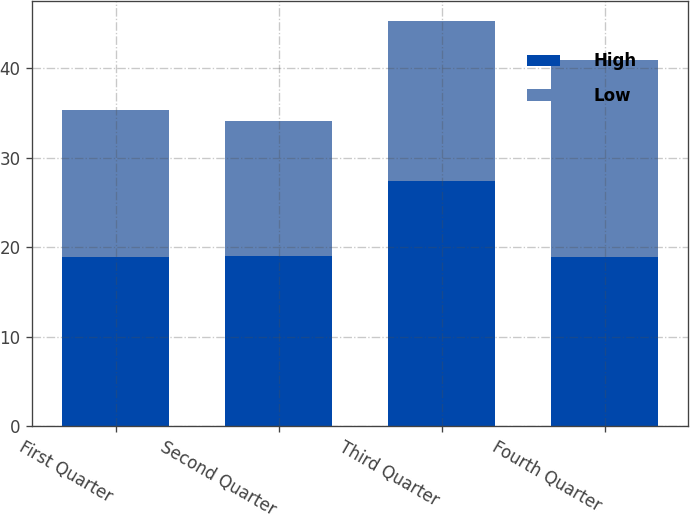<chart> <loc_0><loc_0><loc_500><loc_500><stacked_bar_chart><ecel><fcel>First Quarter<fcel>Second Quarter<fcel>Third Quarter<fcel>Fourth Quarter<nl><fcel>High<fcel>18.9<fcel>19<fcel>27.42<fcel>18.9<nl><fcel>Low<fcel>16.47<fcel>15.13<fcel>17.9<fcel>22.09<nl></chart> 